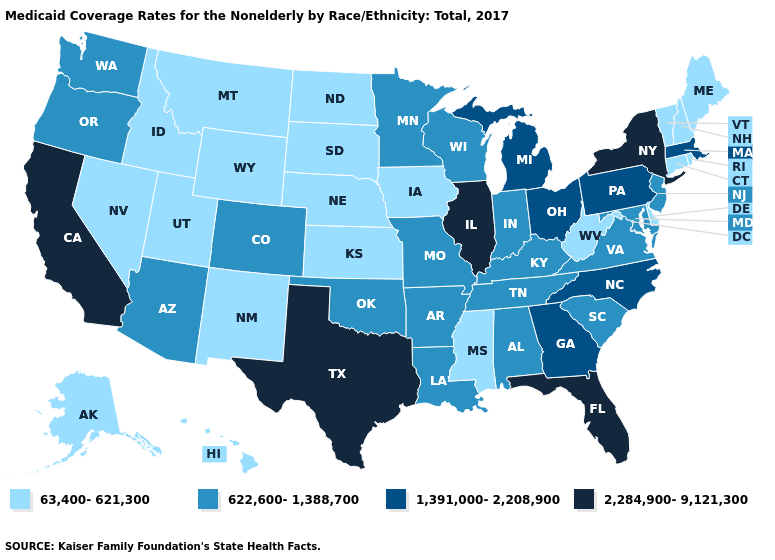Does Montana have the highest value in the USA?
Keep it brief. No. What is the value of Pennsylvania?
Write a very short answer. 1,391,000-2,208,900. Among the states that border Oregon , which have the highest value?
Write a very short answer. California. Which states have the lowest value in the USA?
Short answer required. Alaska, Connecticut, Delaware, Hawaii, Idaho, Iowa, Kansas, Maine, Mississippi, Montana, Nebraska, Nevada, New Hampshire, New Mexico, North Dakota, Rhode Island, South Dakota, Utah, Vermont, West Virginia, Wyoming. Which states have the highest value in the USA?
Give a very brief answer. California, Florida, Illinois, New York, Texas. Name the states that have a value in the range 2,284,900-9,121,300?
Answer briefly. California, Florida, Illinois, New York, Texas. What is the value of South Carolina?
Concise answer only. 622,600-1,388,700. What is the value of New Hampshire?
Quick response, please. 63,400-621,300. Which states have the lowest value in the Northeast?
Short answer required. Connecticut, Maine, New Hampshire, Rhode Island, Vermont. What is the value of Delaware?
Answer briefly. 63,400-621,300. What is the value of Alaska?
Write a very short answer. 63,400-621,300. Which states have the lowest value in the MidWest?
Be succinct. Iowa, Kansas, Nebraska, North Dakota, South Dakota. Name the states that have a value in the range 2,284,900-9,121,300?
Quick response, please. California, Florida, Illinois, New York, Texas. What is the value of Ohio?
Be succinct. 1,391,000-2,208,900. What is the value of Maine?
Be succinct. 63,400-621,300. 